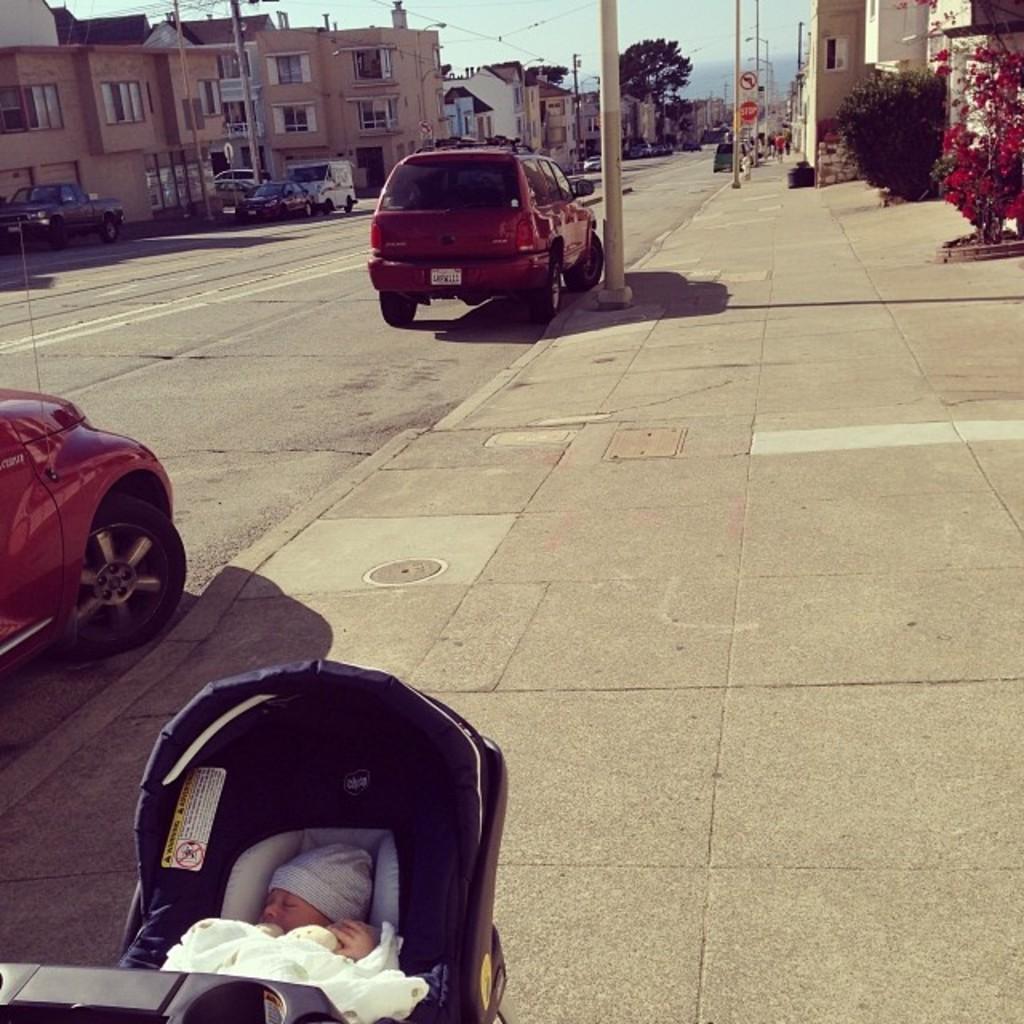Can you describe this image briefly? This picture is clicked outside. In the foreground we can see an infant in a stroller. On the left we can see there are many number of vehicles seems to be parked on the ground. On the right we can see the plants and buildings. In the background there is a ski, poles, trees and buildings. 